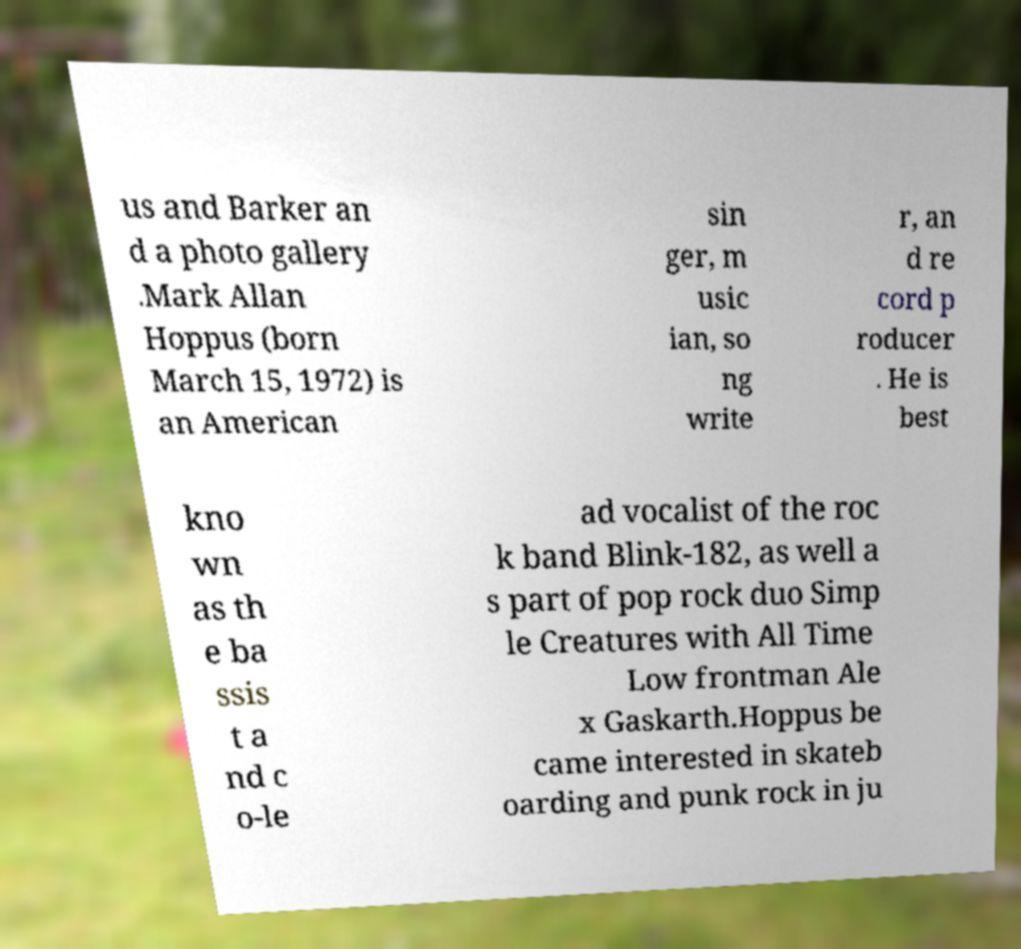There's text embedded in this image that I need extracted. Can you transcribe it verbatim? us and Barker an d a photo gallery .Mark Allan Hoppus (born March 15, 1972) is an American sin ger, m usic ian, so ng write r, an d re cord p roducer . He is best kno wn as th e ba ssis t a nd c o-le ad vocalist of the roc k band Blink-182, as well a s part of pop rock duo Simp le Creatures with All Time Low frontman Ale x Gaskarth.Hoppus be came interested in skateb oarding and punk rock in ju 